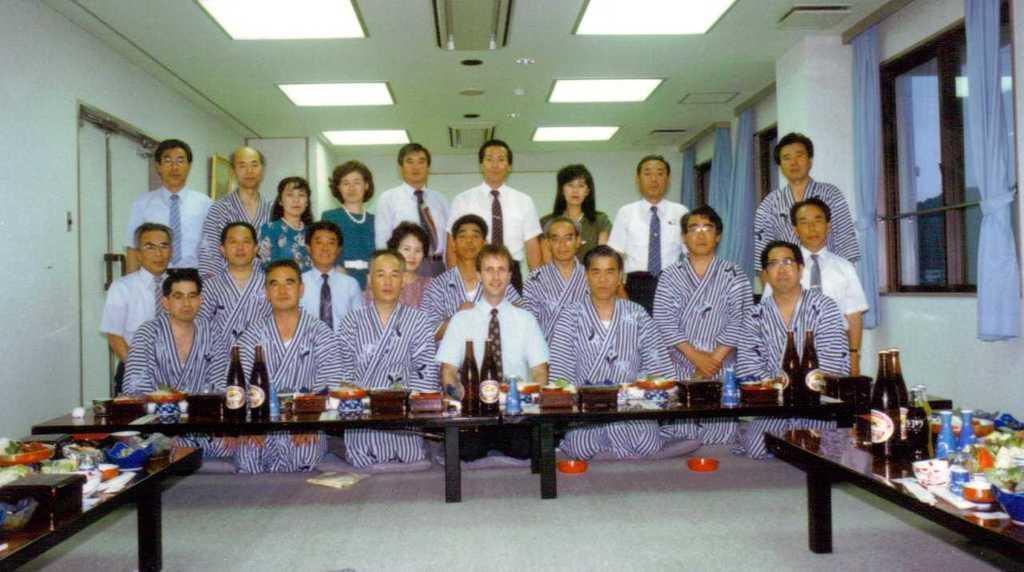Describe this image in one or two sentences. In this picture there are many people. The people with blue strips dress are sitting. And some people are standing. In front of them there is a table. On the table there are some bottle, boxes, bowels and other objects. To the left side there is a door and to the right side there is a window with curtains. 